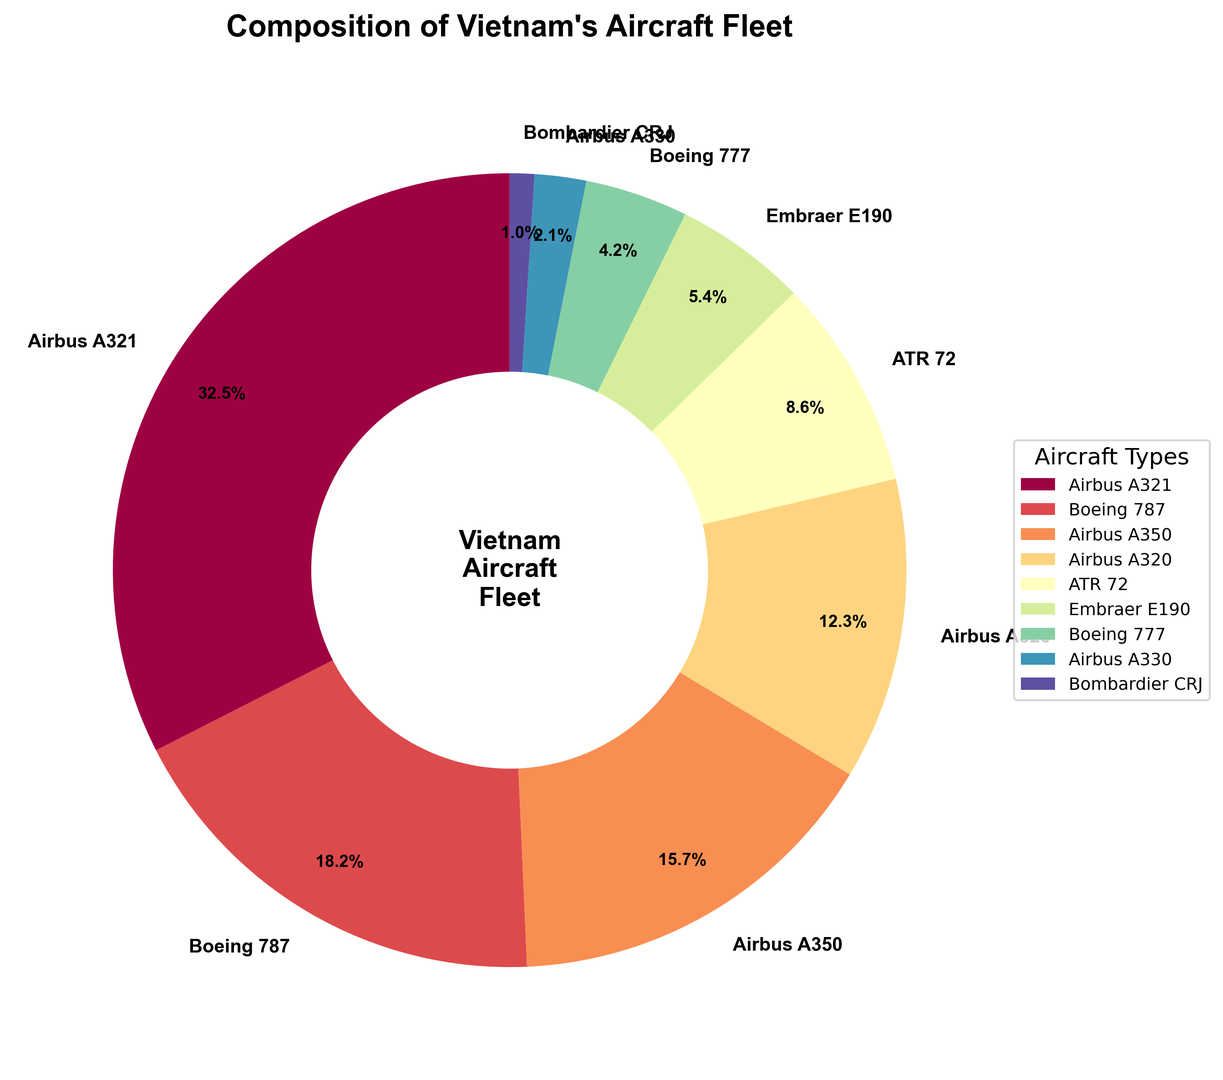Which aircraft type constitutes the largest portion of the fleet? The pie chart shows that the largest wedge corresponds to the Airbus A321 segment, indicating it has the highest percentage of the total fleet.
Answer: Airbus A321 What is the percentage difference between Airbus A321 and Boeing 787 in the fleet composition? Airbus A321 constitutes 32.5% and Boeing 787 makes up 18.2%. The difference is calculated as 32.5% - 18.2% = 14.3%.
Answer: 14.3% Which aircraft types make up less than 5% of the fleet? Referring to the pie chart, the segments labeled with percentages less than 5% are Boeing 777, Airbus A330, and Bombardier CRJ, which have 4.2%, 2.1%, and 1.0%, respectively.
Answer: Boeing 777, Airbus A330, Bombardier CRJ How many aircraft types make up more than 15% of the fleet? Observing the pie chart, three segments have percentages higher than 15%: Airbus A321 (32.5%), Boeing 787 (18.2%), and Airbus A350 (15.7%).
Answer: 3 What is the combined percentage of Airbus A320 and ATR 72 in the fleet? According to the chart, Airbus A320 constitutes 12.3% and ATR 72 makes up 8.6% of the fleet. Adding these gives 12.3% + 8.6% = 20.9%.
Answer: 20.9% Which aircraft type has a very similar share to that of Airbus A350? Comparing the segments, the percentages of Airbus A350 (15.7%) and Boeing 787 (18.2%) are quite close, with only a small difference of 2.5%.
Answer: Boeing 787 Is the percentage of Bombardier CRJ greater than or less than Embraer E190? The pie chart indicates Bombardier CRJ is at 1.0%, and Embraer E190 is at 5.4%. Thus, Bombardier CRJ's percentage is less than Embraer E190.
Answer: Less What is the average percentage of the Boeing aircraft in the fleet? The Boeing aircraft included are Boeing 787 (18.2%) and Boeing 777 (4.2%). The average is calculated as (18.2% + 4.2%) / 2 = 11.2%.
Answer: 11.2% Which aircraft type has the smallest percentage in the fleet? The chart shows the smallest wedge representing Bombardier CRJ which constitutes 1.0% of the fleet.
Answer: Bombardier CRJ 